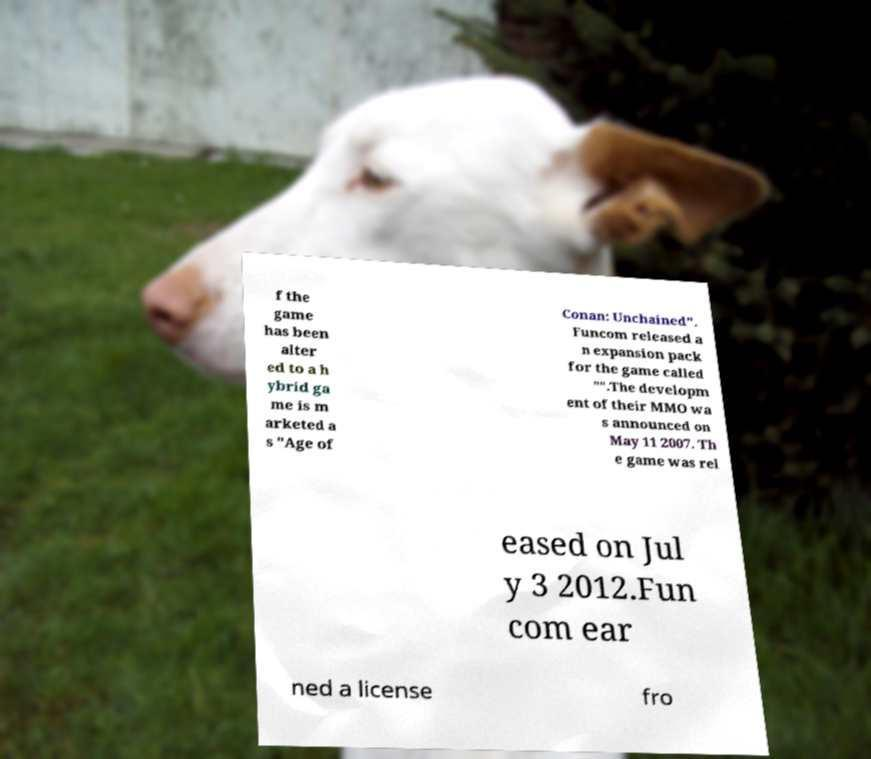Can you read and provide the text displayed in the image?This photo seems to have some interesting text. Can you extract and type it out for me? f the game has been alter ed to a h ybrid ga me is m arketed a s "Age of Conan: Unchained". Funcom released a n expansion pack for the game called "".The developm ent of their MMO wa s announced on May 11 2007. Th e game was rel eased on Jul y 3 2012.Fun com ear ned a license fro 